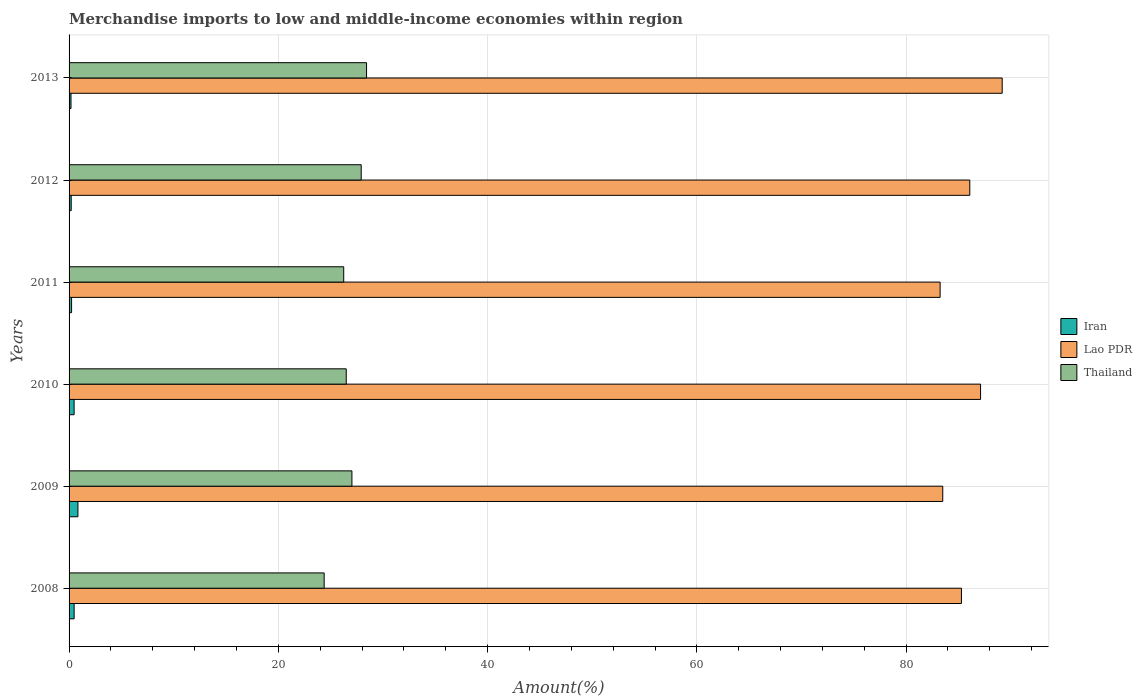How many bars are there on the 6th tick from the bottom?
Offer a very short reply. 3. What is the percentage of amount earned from merchandise imports in Iran in 2008?
Ensure brevity in your answer.  0.48. Across all years, what is the maximum percentage of amount earned from merchandise imports in Lao PDR?
Provide a succinct answer. 89.18. Across all years, what is the minimum percentage of amount earned from merchandise imports in Iran?
Make the answer very short. 0.18. In which year was the percentage of amount earned from merchandise imports in Lao PDR maximum?
Offer a very short reply. 2013. In which year was the percentage of amount earned from merchandise imports in Lao PDR minimum?
Provide a short and direct response. 2011. What is the total percentage of amount earned from merchandise imports in Lao PDR in the graph?
Ensure brevity in your answer.  514.42. What is the difference between the percentage of amount earned from merchandise imports in Thailand in 2009 and that in 2010?
Your answer should be compact. 0.54. What is the difference between the percentage of amount earned from merchandise imports in Iran in 2013 and the percentage of amount earned from merchandise imports in Thailand in 2012?
Your answer should be very brief. -27.74. What is the average percentage of amount earned from merchandise imports in Lao PDR per year?
Offer a very short reply. 85.74. In the year 2013, what is the difference between the percentage of amount earned from merchandise imports in Thailand and percentage of amount earned from merchandise imports in Lao PDR?
Give a very brief answer. -60.75. In how many years, is the percentage of amount earned from merchandise imports in Lao PDR greater than 16 %?
Offer a terse response. 6. What is the ratio of the percentage of amount earned from merchandise imports in Thailand in 2009 to that in 2010?
Your response must be concise. 1.02. Is the difference between the percentage of amount earned from merchandise imports in Thailand in 2009 and 2010 greater than the difference between the percentage of amount earned from merchandise imports in Lao PDR in 2009 and 2010?
Offer a very short reply. Yes. What is the difference between the highest and the second highest percentage of amount earned from merchandise imports in Lao PDR?
Ensure brevity in your answer.  2.07. What is the difference between the highest and the lowest percentage of amount earned from merchandise imports in Iran?
Keep it short and to the point. 0.66. What does the 1st bar from the top in 2009 represents?
Offer a terse response. Thailand. What does the 3rd bar from the bottom in 2008 represents?
Your answer should be compact. Thailand. Is it the case that in every year, the sum of the percentage of amount earned from merchandise imports in Iran and percentage of amount earned from merchandise imports in Thailand is greater than the percentage of amount earned from merchandise imports in Lao PDR?
Your answer should be compact. No. Are all the bars in the graph horizontal?
Your answer should be very brief. Yes. Are the values on the major ticks of X-axis written in scientific E-notation?
Provide a succinct answer. No. Does the graph contain any zero values?
Ensure brevity in your answer.  No. Does the graph contain grids?
Make the answer very short. Yes. How are the legend labels stacked?
Ensure brevity in your answer.  Vertical. What is the title of the graph?
Make the answer very short. Merchandise imports to low and middle-income economies within region. Does "North America" appear as one of the legend labels in the graph?
Make the answer very short. No. What is the label or title of the X-axis?
Ensure brevity in your answer.  Amount(%). What is the Amount(%) of Iran in 2008?
Make the answer very short. 0.48. What is the Amount(%) in Lao PDR in 2008?
Provide a succinct answer. 85.29. What is the Amount(%) of Thailand in 2008?
Offer a terse response. 24.38. What is the Amount(%) in Iran in 2009?
Make the answer very short. 0.85. What is the Amount(%) of Lao PDR in 2009?
Ensure brevity in your answer.  83.5. What is the Amount(%) of Thailand in 2009?
Keep it short and to the point. 27.03. What is the Amount(%) in Iran in 2010?
Your response must be concise. 0.48. What is the Amount(%) in Lao PDR in 2010?
Make the answer very short. 87.11. What is the Amount(%) of Thailand in 2010?
Your answer should be compact. 26.49. What is the Amount(%) in Iran in 2011?
Keep it short and to the point. 0.24. What is the Amount(%) of Lao PDR in 2011?
Give a very brief answer. 83.25. What is the Amount(%) of Thailand in 2011?
Provide a short and direct response. 26.25. What is the Amount(%) of Iran in 2012?
Provide a short and direct response. 0.2. What is the Amount(%) in Lao PDR in 2012?
Provide a short and direct response. 86.09. What is the Amount(%) of Thailand in 2012?
Offer a very short reply. 27.92. What is the Amount(%) in Iran in 2013?
Your response must be concise. 0.18. What is the Amount(%) of Lao PDR in 2013?
Ensure brevity in your answer.  89.18. What is the Amount(%) in Thailand in 2013?
Make the answer very short. 28.43. Across all years, what is the maximum Amount(%) in Iran?
Give a very brief answer. 0.85. Across all years, what is the maximum Amount(%) of Lao PDR?
Offer a very short reply. 89.18. Across all years, what is the maximum Amount(%) in Thailand?
Offer a terse response. 28.43. Across all years, what is the minimum Amount(%) in Iran?
Provide a short and direct response. 0.18. Across all years, what is the minimum Amount(%) in Lao PDR?
Offer a very short reply. 83.25. Across all years, what is the minimum Amount(%) in Thailand?
Offer a terse response. 24.38. What is the total Amount(%) in Iran in the graph?
Keep it short and to the point. 2.44. What is the total Amount(%) of Lao PDR in the graph?
Provide a short and direct response. 514.42. What is the total Amount(%) in Thailand in the graph?
Your response must be concise. 160.5. What is the difference between the Amount(%) in Iran in 2008 and that in 2009?
Your response must be concise. -0.36. What is the difference between the Amount(%) in Lao PDR in 2008 and that in 2009?
Provide a short and direct response. 1.79. What is the difference between the Amount(%) in Thailand in 2008 and that in 2009?
Provide a succinct answer. -2.65. What is the difference between the Amount(%) in Iran in 2008 and that in 2010?
Give a very brief answer. 0. What is the difference between the Amount(%) of Lao PDR in 2008 and that in 2010?
Your answer should be very brief. -1.83. What is the difference between the Amount(%) of Thailand in 2008 and that in 2010?
Offer a very short reply. -2.11. What is the difference between the Amount(%) in Iran in 2008 and that in 2011?
Keep it short and to the point. 0.24. What is the difference between the Amount(%) in Lao PDR in 2008 and that in 2011?
Your answer should be compact. 2.04. What is the difference between the Amount(%) in Thailand in 2008 and that in 2011?
Provide a succinct answer. -1.87. What is the difference between the Amount(%) of Iran in 2008 and that in 2012?
Make the answer very short. 0.28. What is the difference between the Amount(%) in Lao PDR in 2008 and that in 2012?
Ensure brevity in your answer.  -0.8. What is the difference between the Amount(%) of Thailand in 2008 and that in 2012?
Keep it short and to the point. -3.54. What is the difference between the Amount(%) of Iran in 2008 and that in 2013?
Your response must be concise. 0.3. What is the difference between the Amount(%) of Lao PDR in 2008 and that in 2013?
Give a very brief answer. -3.89. What is the difference between the Amount(%) of Thailand in 2008 and that in 2013?
Provide a short and direct response. -4.05. What is the difference between the Amount(%) in Iran in 2009 and that in 2010?
Give a very brief answer. 0.37. What is the difference between the Amount(%) of Lao PDR in 2009 and that in 2010?
Ensure brevity in your answer.  -3.61. What is the difference between the Amount(%) in Thailand in 2009 and that in 2010?
Provide a short and direct response. 0.54. What is the difference between the Amount(%) in Iran in 2009 and that in 2011?
Give a very brief answer. 0.61. What is the difference between the Amount(%) in Lao PDR in 2009 and that in 2011?
Offer a very short reply. 0.25. What is the difference between the Amount(%) of Thailand in 2009 and that in 2011?
Your response must be concise. 0.78. What is the difference between the Amount(%) of Iran in 2009 and that in 2012?
Keep it short and to the point. 0.64. What is the difference between the Amount(%) in Lao PDR in 2009 and that in 2012?
Offer a terse response. -2.59. What is the difference between the Amount(%) of Thailand in 2009 and that in 2012?
Keep it short and to the point. -0.89. What is the difference between the Amount(%) in Iran in 2009 and that in 2013?
Provide a succinct answer. 0.66. What is the difference between the Amount(%) of Lao PDR in 2009 and that in 2013?
Provide a short and direct response. -5.68. What is the difference between the Amount(%) of Thailand in 2009 and that in 2013?
Give a very brief answer. -1.4. What is the difference between the Amount(%) of Iran in 2010 and that in 2011?
Offer a very short reply. 0.24. What is the difference between the Amount(%) in Lao PDR in 2010 and that in 2011?
Make the answer very short. 3.86. What is the difference between the Amount(%) of Thailand in 2010 and that in 2011?
Your answer should be compact. 0.24. What is the difference between the Amount(%) of Iran in 2010 and that in 2012?
Offer a terse response. 0.28. What is the difference between the Amount(%) of Lao PDR in 2010 and that in 2012?
Your answer should be compact. 1.03. What is the difference between the Amount(%) of Thailand in 2010 and that in 2012?
Offer a very short reply. -1.43. What is the difference between the Amount(%) in Iran in 2010 and that in 2013?
Offer a terse response. 0.3. What is the difference between the Amount(%) in Lao PDR in 2010 and that in 2013?
Offer a very short reply. -2.07. What is the difference between the Amount(%) of Thailand in 2010 and that in 2013?
Your response must be concise. -1.94. What is the difference between the Amount(%) of Iran in 2011 and that in 2012?
Your response must be concise. 0.04. What is the difference between the Amount(%) of Lao PDR in 2011 and that in 2012?
Offer a terse response. -2.84. What is the difference between the Amount(%) in Thailand in 2011 and that in 2012?
Make the answer very short. -1.67. What is the difference between the Amount(%) of Iran in 2011 and that in 2013?
Offer a very short reply. 0.06. What is the difference between the Amount(%) in Lao PDR in 2011 and that in 2013?
Make the answer very short. -5.93. What is the difference between the Amount(%) of Thailand in 2011 and that in 2013?
Keep it short and to the point. -2.18. What is the difference between the Amount(%) of Iran in 2012 and that in 2013?
Make the answer very short. 0.02. What is the difference between the Amount(%) in Lao PDR in 2012 and that in 2013?
Offer a terse response. -3.1. What is the difference between the Amount(%) of Thailand in 2012 and that in 2013?
Offer a very short reply. -0.51. What is the difference between the Amount(%) of Iran in 2008 and the Amount(%) of Lao PDR in 2009?
Provide a short and direct response. -83.02. What is the difference between the Amount(%) of Iran in 2008 and the Amount(%) of Thailand in 2009?
Make the answer very short. -26.55. What is the difference between the Amount(%) in Lao PDR in 2008 and the Amount(%) in Thailand in 2009?
Provide a short and direct response. 58.26. What is the difference between the Amount(%) of Iran in 2008 and the Amount(%) of Lao PDR in 2010?
Your response must be concise. -86.63. What is the difference between the Amount(%) in Iran in 2008 and the Amount(%) in Thailand in 2010?
Offer a very short reply. -26.01. What is the difference between the Amount(%) in Lao PDR in 2008 and the Amount(%) in Thailand in 2010?
Your answer should be compact. 58.8. What is the difference between the Amount(%) in Iran in 2008 and the Amount(%) in Lao PDR in 2011?
Ensure brevity in your answer.  -82.77. What is the difference between the Amount(%) in Iran in 2008 and the Amount(%) in Thailand in 2011?
Your answer should be compact. -25.77. What is the difference between the Amount(%) of Lao PDR in 2008 and the Amount(%) of Thailand in 2011?
Your answer should be very brief. 59.04. What is the difference between the Amount(%) of Iran in 2008 and the Amount(%) of Lao PDR in 2012?
Give a very brief answer. -85.6. What is the difference between the Amount(%) in Iran in 2008 and the Amount(%) in Thailand in 2012?
Make the answer very short. -27.44. What is the difference between the Amount(%) in Lao PDR in 2008 and the Amount(%) in Thailand in 2012?
Keep it short and to the point. 57.37. What is the difference between the Amount(%) of Iran in 2008 and the Amount(%) of Lao PDR in 2013?
Ensure brevity in your answer.  -88.7. What is the difference between the Amount(%) in Iran in 2008 and the Amount(%) in Thailand in 2013?
Give a very brief answer. -27.95. What is the difference between the Amount(%) in Lao PDR in 2008 and the Amount(%) in Thailand in 2013?
Your answer should be compact. 56.86. What is the difference between the Amount(%) of Iran in 2009 and the Amount(%) of Lao PDR in 2010?
Offer a terse response. -86.27. What is the difference between the Amount(%) in Iran in 2009 and the Amount(%) in Thailand in 2010?
Offer a terse response. -25.64. What is the difference between the Amount(%) in Lao PDR in 2009 and the Amount(%) in Thailand in 2010?
Provide a succinct answer. 57.01. What is the difference between the Amount(%) of Iran in 2009 and the Amount(%) of Lao PDR in 2011?
Your response must be concise. -82.4. What is the difference between the Amount(%) of Iran in 2009 and the Amount(%) of Thailand in 2011?
Offer a very short reply. -25.4. What is the difference between the Amount(%) in Lao PDR in 2009 and the Amount(%) in Thailand in 2011?
Keep it short and to the point. 57.25. What is the difference between the Amount(%) in Iran in 2009 and the Amount(%) in Lao PDR in 2012?
Keep it short and to the point. -85.24. What is the difference between the Amount(%) of Iran in 2009 and the Amount(%) of Thailand in 2012?
Give a very brief answer. -27.07. What is the difference between the Amount(%) in Lao PDR in 2009 and the Amount(%) in Thailand in 2012?
Ensure brevity in your answer.  55.58. What is the difference between the Amount(%) of Iran in 2009 and the Amount(%) of Lao PDR in 2013?
Make the answer very short. -88.34. What is the difference between the Amount(%) in Iran in 2009 and the Amount(%) in Thailand in 2013?
Keep it short and to the point. -27.58. What is the difference between the Amount(%) in Lao PDR in 2009 and the Amount(%) in Thailand in 2013?
Your response must be concise. 55.07. What is the difference between the Amount(%) of Iran in 2010 and the Amount(%) of Lao PDR in 2011?
Offer a terse response. -82.77. What is the difference between the Amount(%) of Iran in 2010 and the Amount(%) of Thailand in 2011?
Make the answer very short. -25.77. What is the difference between the Amount(%) of Lao PDR in 2010 and the Amount(%) of Thailand in 2011?
Ensure brevity in your answer.  60.86. What is the difference between the Amount(%) in Iran in 2010 and the Amount(%) in Lao PDR in 2012?
Ensure brevity in your answer.  -85.61. What is the difference between the Amount(%) in Iran in 2010 and the Amount(%) in Thailand in 2012?
Give a very brief answer. -27.44. What is the difference between the Amount(%) of Lao PDR in 2010 and the Amount(%) of Thailand in 2012?
Provide a succinct answer. 59.2. What is the difference between the Amount(%) in Iran in 2010 and the Amount(%) in Lao PDR in 2013?
Give a very brief answer. -88.7. What is the difference between the Amount(%) in Iran in 2010 and the Amount(%) in Thailand in 2013?
Your answer should be very brief. -27.95. What is the difference between the Amount(%) in Lao PDR in 2010 and the Amount(%) in Thailand in 2013?
Your answer should be compact. 58.68. What is the difference between the Amount(%) of Iran in 2011 and the Amount(%) of Lao PDR in 2012?
Provide a short and direct response. -85.85. What is the difference between the Amount(%) in Iran in 2011 and the Amount(%) in Thailand in 2012?
Ensure brevity in your answer.  -27.68. What is the difference between the Amount(%) of Lao PDR in 2011 and the Amount(%) of Thailand in 2012?
Your answer should be very brief. 55.33. What is the difference between the Amount(%) of Iran in 2011 and the Amount(%) of Lao PDR in 2013?
Make the answer very short. -88.94. What is the difference between the Amount(%) of Iran in 2011 and the Amount(%) of Thailand in 2013?
Your response must be concise. -28.19. What is the difference between the Amount(%) of Lao PDR in 2011 and the Amount(%) of Thailand in 2013?
Keep it short and to the point. 54.82. What is the difference between the Amount(%) in Iran in 2012 and the Amount(%) in Lao PDR in 2013?
Your answer should be compact. -88.98. What is the difference between the Amount(%) of Iran in 2012 and the Amount(%) of Thailand in 2013?
Give a very brief answer. -28.23. What is the difference between the Amount(%) in Lao PDR in 2012 and the Amount(%) in Thailand in 2013?
Provide a succinct answer. 57.66. What is the average Amount(%) in Iran per year?
Offer a terse response. 0.41. What is the average Amount(%) in Lao PDR per year?
Ensure brevity in your answer.  85.74. What is the average Amount(%) of Thailand per year?
Your answer should be compact. 26.75. In the year 2008, what is the difference between the Amount(%) of Iran and Amount(%) of Lao PDR?
Ensure brevity in your answer.  -84.8. In the year 2008, what is the difference between the Amount(%) in Iran and Amount(%) in Thailand?
Keep it short and to the point. -23.9. In the year 2008, what is the difference between the Amount(%) in Lao PDR and Amount(%) in Thailand?
Your answer should be compact. 60.91. In the year 2009, what is the difference between the Amount(%) in Iran and Amount(%) in Lao PDR?
Provide a succinct answer. -82.65. In the year 2009, what is the difference between the Amount(%) of Iran and Amount(%) of Thailand?
Keep it short and to the point. -26.19. In the year 2009, what is the difference between the Amount(%) in Lao PDR and Amount(%) in Thailand?
Provide a short and direct response. 56.47. In the year 2010, what is the difference between the Amount(%) in Iran and Amount(%) in Lao PDR?
Provide a succinct answer. -86.63. In the year 2010, what is the difference between the Amount(%) of Iran and Amount(%) of Thailand?
Your answer should be compact. -26.01. In the year 2010, what is the difference between the Amount(%) of Lao PDR and Amount(%) of Thailand?
Your answer should be compact. 60.62. In the year 2011, what is the difference between the Amount(%) of Iran and Amount(%) of Lao PDR?
Ensure brevity in your answer.  -83.01. In the year 2011, what is the difference between the Amount(%) in Iran and Amount(%) in Thailand?
Ensure brevity in your answer.  -26.01. In the year 2011, what is the difference between the Amount(%) of Lao PDR and Amount(%) of Thailand?
Give a very brief answer. 57. In the year 2012, what is the difference between the Amount(%) of Iran and Amount(%) of Lao PDR?
Your response must be concise. -85.88. In the year 2012, what is the difference between the Amount(%) in Iran and Amount(%) in Thailand?
Make the answer very short. -27.72. In the year 2012, what is the difference between the Amount(%) in Lao PDR and Amount(%) in Thailand?
Offer a very short reply. 58.17. In the year 2013, what is the difference between the Amount(%) in Iran and Amount(%) in Lao PDR?
Make the answer very short. -89. In the year 2013, what is the difference between the Amount(%) of Iran and Amount(%) of Thailand?
Ensure brevity in your answer.  -28.25. In the year 2013, what is the difference between the Amount(%) of Lao PDR and Amount(%) of Thailand?
Keep it short and to the point. 60.75. What is the ratio of the Amount(%) in Iran in 2008 to that in 2009?
Provide a short and direct response. 0.57. What is the ratio of the Amount(%) in Lao PDR in 2008 to that in 2009?
Make the answer very short. 1.02. What is the ratio of the Amount(%) of Thailand in 2008 to that in 2009?
Your answer should be compact. 0.9. What is the ratio of the Amount(%) in Iran in 2008 to that in 2010?
Your response must be concise. 1. What is the ratio of the Amount(%) in Lao PDR in 2008 to that in 2010?
Offer a very short reply. 0.98. What is the ratio of the Amount(%) in Thailand in 2008 to that in 2010?
Ensure brevity in your answer.  0.92. What is the ratio of the Amount(%) in Iran in 2008 to that in 2011?
Give a very brief answer. 2.01. What is the ratio of the Amount(%) in Lao PDR in 2008 to that in 2011?
Ensure brevity in your answer.  1.02. What is the ratio of the Amount(%) of Thailand in 2008 to that in 2011?
Offer a terse response. 0.93. What is the ratio of the Amount(%) in Iran in 2008 to that in 2012?
Make the answer very short. 2.36. What is the ratio of the Amount(%) of Thailand in 2008 to that in 2012?
Make the answer very short. 0.87. What is the ratio of the Amount(%) in Iran in 2008 to that in 2013?
Offer a terse response. 2.63. What is the ratio of the Amount(%) in Lao PDR in 2008 to that in 2013?
Provide a short and direct response. 0.96. What is the ratio of the Amount(%) in Thailand in 2008 to that in 2013?
Keep it short and to the point. 0.86. What is the ratio of the Amount(%) in Iran in 2009 to that in 2010?
Offer a terse response. 1.76. What is the ratio of the Amount(%) in Lao PDR in 2009 to that in 2010?
Provide a short and direct response. 0.96. What is the ratio of the Amount(%) of Thailand in 2009 to that in 2010?
Your answer should be very brief. 1.02. What is the ratio of the Amount(%) in Iran in 2009 to that in 2011?
Offer a terse response. 3.53. What is the ratio of the Amount(%) in Thailand in 2009 to that in 2011?
Offer a very short reply. 1.03. What is the ratio of the Amount(%) of Iran in 2009 to that in 2012?
Offer a very short reply. 4.14. What is the ratio of the Amount(%) of Thailand in 2009 to that in 2012?
Your response must be concise. 0.97. What is the ratio of the Amount(%) in Iran in 2009 to that in 2013?
Ensure brevity in your answer.  4.6. What is the ratio of the Amount(%) of Lao PDR in 2009 to that in 2013?
Your response must be concise. 0.94. What is the ratio of the Amount(%) of Thailand in 2009 to that in 2013?
Give a very brief answer. 0.95. What is the ratio of the Amount(%) of Iran in 2010 to that in 2011?
Give a very brief answer. 2. What is the ratio of the Amount(%) of Lao PDR in 2010 to that in 2011?
Offer a very short reply. 1.05. What is the ratio of the Amount(%) in Thailand in 2010 to that in 2011?
Give a very brief answer. 1.01. What is the ratio of the Amount(%) of Iran in 2010 to that in 2012?
Your answer should be compact. 2.35. What is the ratio of the Amount(%) in Lao PDR in 2010 to that in 2012?
Offer a very short reply. 1.01. What is the ratio of the Amount(%) in Thailand in 2010 to that in 2012?
Your answer should be compact. 0.95. What is the ratio of the Amount(%) of Iran in 2010 to that in 2013?
Give a very brief answer. 2.61. What is the ratio of the Amount(%) of Lao PDR in 2010 to that in 2013?
Provide a succinct answer. 0.98. What is the ratio of the Amount(%) of Thailand in 2010 to that in 2013?
Provide a succinct answer. 0.93. What is the ratio of the Amount(%) in Iran in 2011 to that in 2012?
Your answer should be very brief. 1.17. What is the ratio of the Amount(%) in Lao PDR in 2011 to that in 2012?
Keep it short and to the point. 0.97. What is the ratio of the Amount(%) in Thailand in 2011 to that in 2012?
Your answer should be compact. 0.94. What is the ratio of the Amount(%) of Iran in 2011 to that in 2013?
Give a very brief answer. 1.3. What is the ratio of the Amount(%) in Lao PDR in 2011 to that in 2013?
Offer a very short reply. 0.93. What is the ratio of the Amount(%) in Thailand in 2011 to that in 2013?
Keep it short and to the point. 0.92. What is the ratio of the Amount(%) of Iran in 2012 to that in 2013?
Provide a succinct answer. 1.11. What is the ratio of the Amount(%) in Lao PDR in 2012 to that in 2013?
Provide a succinct answer. 0.97. What is the difference between the highest and the second highest Amount(%) of Iran?
Offer a very short reply. 0.36. What is the difference between the highest and the second highest Amount(%) of Lao PDR?
Give a very brief answer. 2.07. What is the difference between the highest and the second highest Amount(%) in Thailand?
Offer a terse response. 0.51. What is the difference between the highest and the lowest Amount(%) in Iran?
Make the answer very short. 0.66. What is the difference between the highest and the lowest Amount(%) in Lao PDR?
Your answer should be very brief. 5.93. What is the difference between the highest and the lowest Amount(%) in Thailand?
Offer a very short reply. 4.05. 